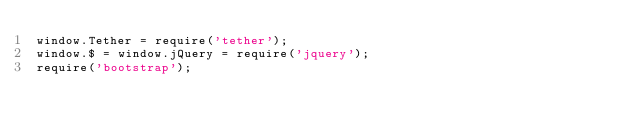<code> <loc_0><loc_0><loc_500><loc_500><_JavaScript_>window.Tether = require('tether');
window.$ = window.jQuery = require('jquery');
require('bootstrap');
</code> 